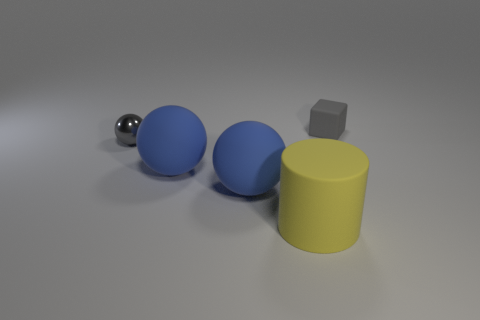Are there more large yellow matte objects than big objects?
Ensure brevity in your answer.  No. Does the gray ball have the same material as the block?
Give a very brief answer. No. How many rubber objects are either large balls or cubes?
Make the answer very short. 3. What is the color of the ball that is the same size as the block?
Make the answer very short. Gray. How many yellow matte objects have the same shape as the shiny thing?
Keep it short and to the point. 0. How many blocks are big objects or tiny metallic objects?
Give a very brief answer. 0. What is the small sphere made of?
Offer a very short reply. Metal. What shape is the metal object that is the same color as the tiny matte object?
Your response must be concise. Sphere. What number of gray rubber things are the same size as the gray block?
Keep it short and to the point. 0. How many objects are either things that are in front of the shiny thing or things that are to the left of the yellow thing?
Offer a very short reply. 4. 